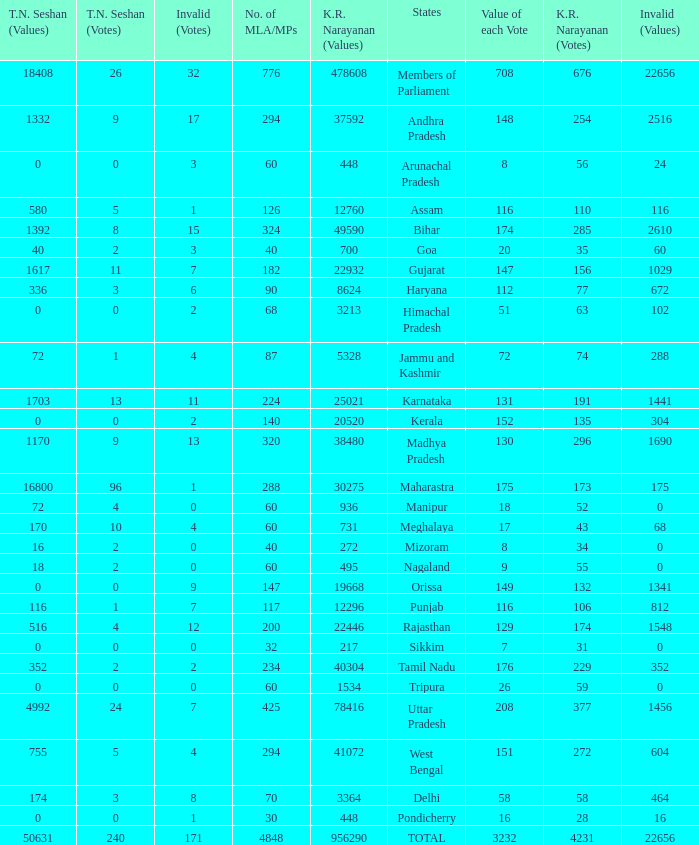Name the most kr votes for value of each vote for 208 377.0. 